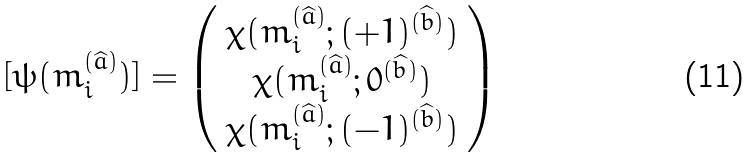<formula> <loc_0><loc_0><loc_500><loc_500>[ \psi ( m _ { i } ^ { ( \widehat { a } ) } ) ] = \left ( \begin{array} { c } \chi ( m _ { i } ^ { ( \widehat { a } ) } ; ( + 1 ) ^ { ( \widehat { b } ) } ) \\ \chi ( m _ { i } ^ { ( \widehat { a } ) } ; 0 ^ { ( \widehat { b } ) } ) \\ \chi ( m _ { i } ^ { ( \widehat { a } ) } ; ( - 1 ) ^ { ( \widehat { b } ) } ) \end{array} \right )</formula> 